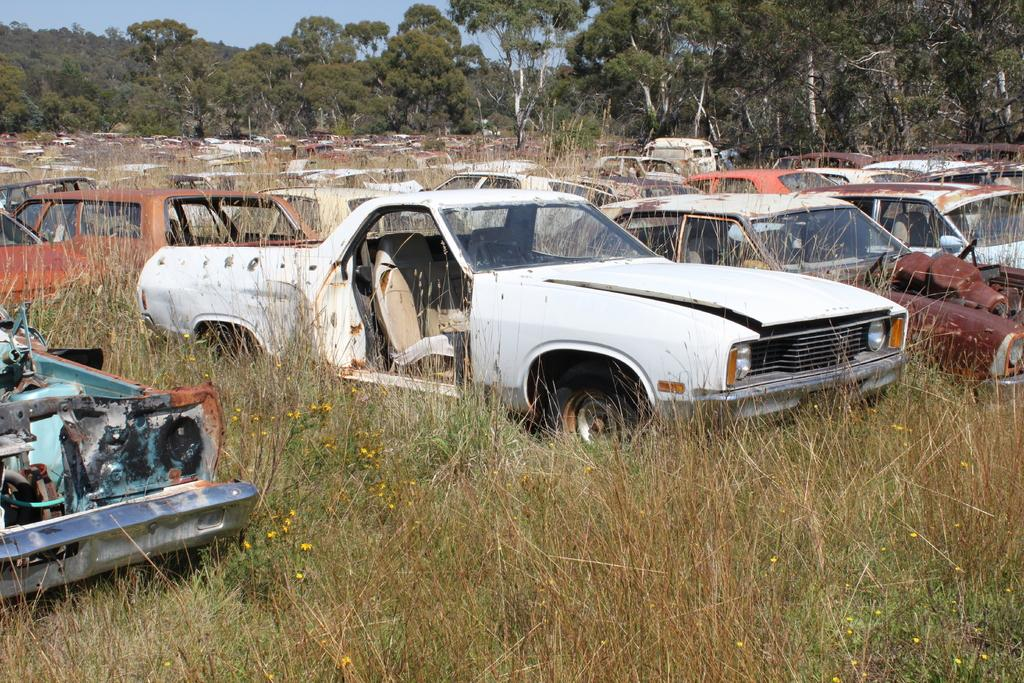What is located on the grassy land in the image? There are cars on the grassy land in the image. What can be seen in the background of the image? There are trees and the sky visible in the background of the image. Reasoning: Let's think step by step in order to produce the conversation. We start by identifying the main subjects in the image, which are the cars on the grassy land. Then, we expand the conversation to include other elements that are also visible, such as the trees and the sky in the background. Each question is designed to elicit a specific detail about the image that is known from the provided facts. Absurd Question/Answer: What type of point is being made by the trees in the image? There is no point being made by the trees in the image; they are simply part of the background. 